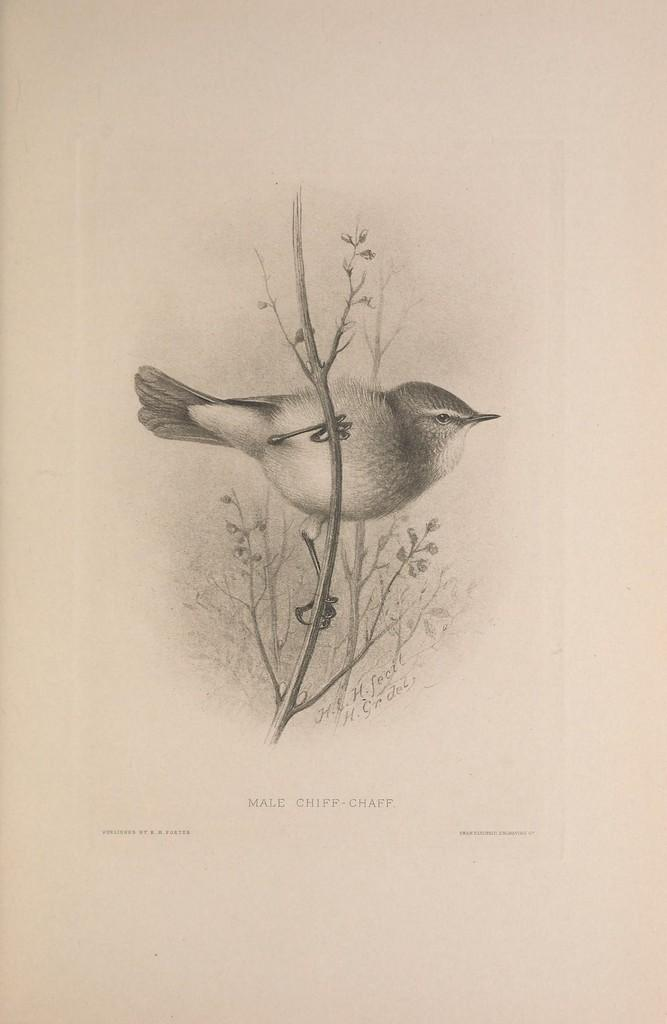What is depicted in the image? There is an art of a bird in the image. Where is the bird located in the image? The bird is on a plant. Are there any additional features visible in the image? Yes, there is a watermark visible in the image. Can you tell me how many sinks are present in the image? There are no sinks present in the image; it features an art of a bird on a plant with a visible watermark. Is there any magic being performed by the bird in the image? There is no magic being performed by the bird in the image; it is simply depicted on a plant. 